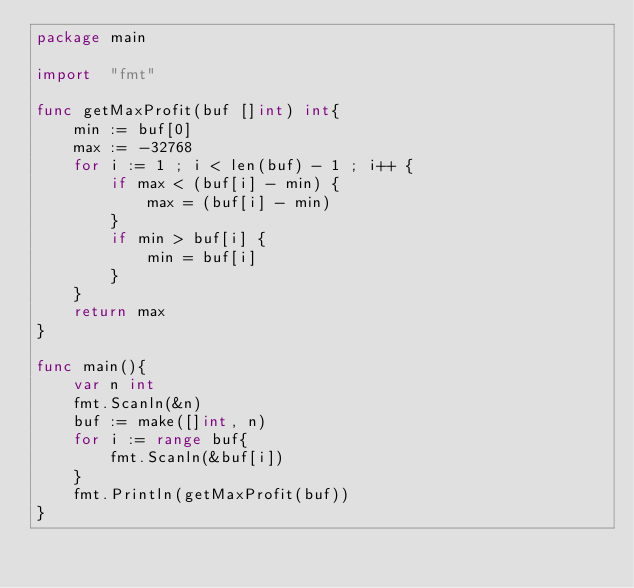<code> <loc_0><loc_0><loc_500><loc_500><_Go_>package main

import  "fmt"

func getMaxProfit(buf []int) int{
    min := buf[0]
    max := -32768
    for i := 1 ; i < len(buf) - 1 ; i++ {
        if max < (buf[i] - min) {
            max = (buf[i] - min)
        }
        if min > buf[i] {
            min = buf[i]
        }
    }
    return max
}

func main(){
    var n int
    fmt.Scanln(&n)
    buf := make([]int, n)
    for i := range buf{
        fmt.Scanln(&buf[i])
    }
    fmt.Println(getMaxProfit(buf))
}
</code> 